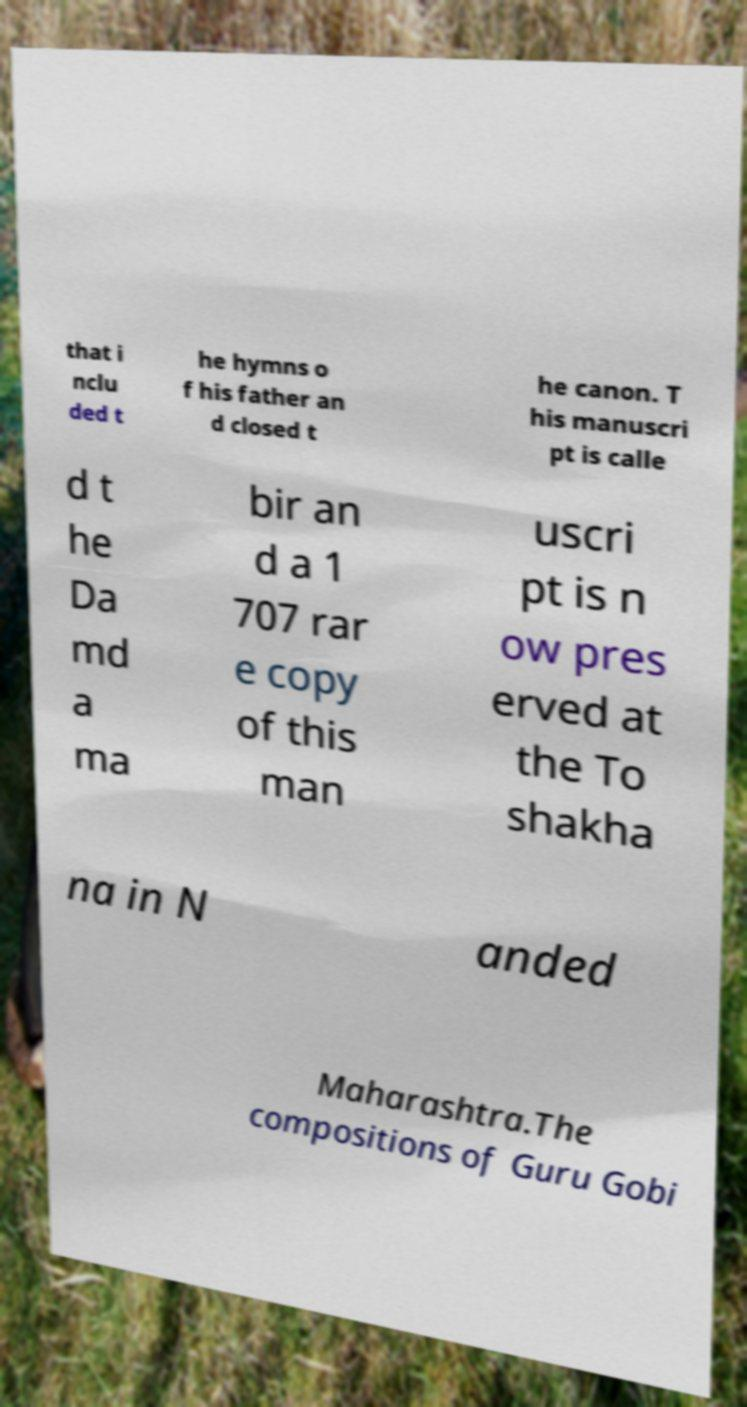What messages or text are displayed in this image? I need them in a readable, typed format. that i nclu ded t he hymns o f his father an d closed t he canon. T his manuscri pt is calle d t he Da md a ma bir an d a 1 707 rar e copy of this man uscri pt is n ow pres erved at the To shakha na in N anded Maharashtra.The compositions of Guru Gobi 